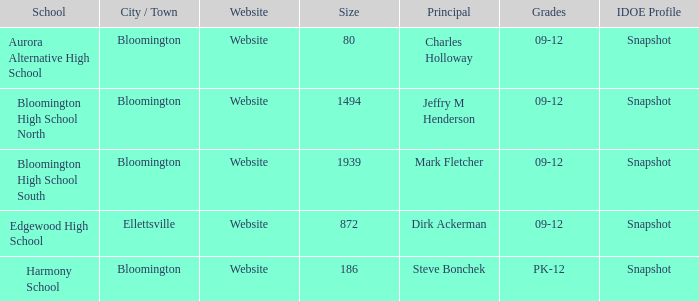Where's the school that Mark Fletcher is the principal of? Bloomington. 